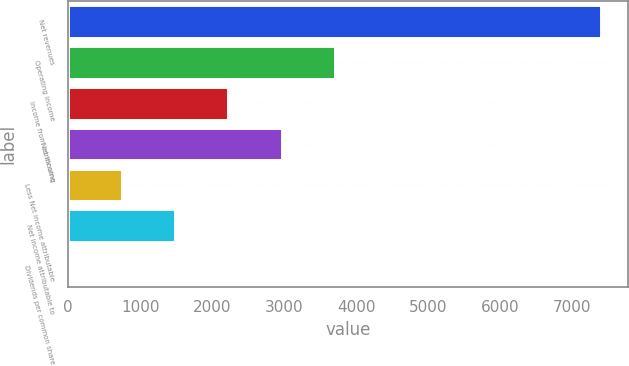Convert chart. <chart><loc_0><loc_0><loc_500><loc_500><bar_chart><fcel>Net revenues<fcel>Operating income<fcel>Income from continuing<fcel>Net income<fcel>Less Net income attributable<fcel>Net income attributable to<fcel>Dividends per common share<nl><fcel>7402<fcel>3701.9<fcel>2221.86<fcel>2961.88<fcel>741.82<fcel>1481.84<fcel>1.8<nl></chart> 